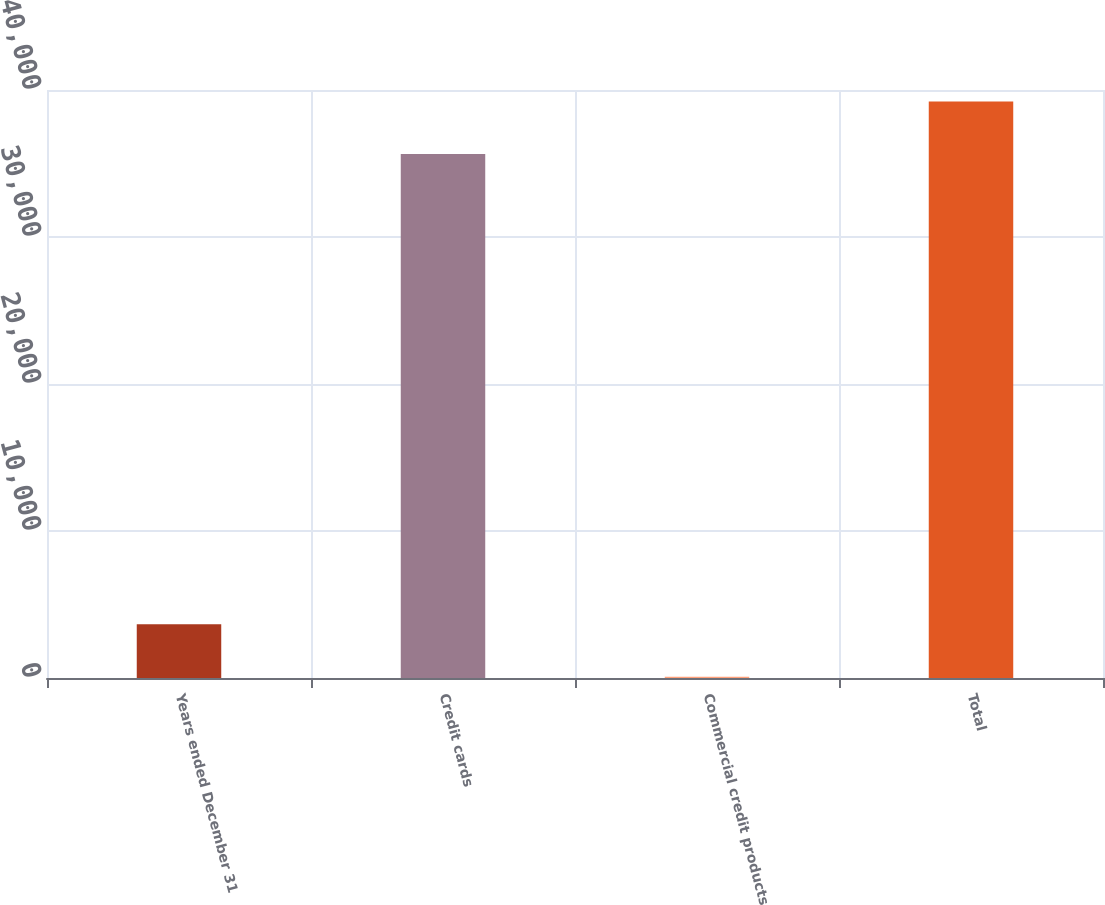<chart> <loc_0><loc_0><loc_500><loc_500><bar_chart><fcel>Years ended December 31<fcel>Credit cards<fcel>Commercial credit products<fcel>Total<nl><fcel>3648.8<fcel>35648<fcel>84<fcel>39212.8<nl></chart> 